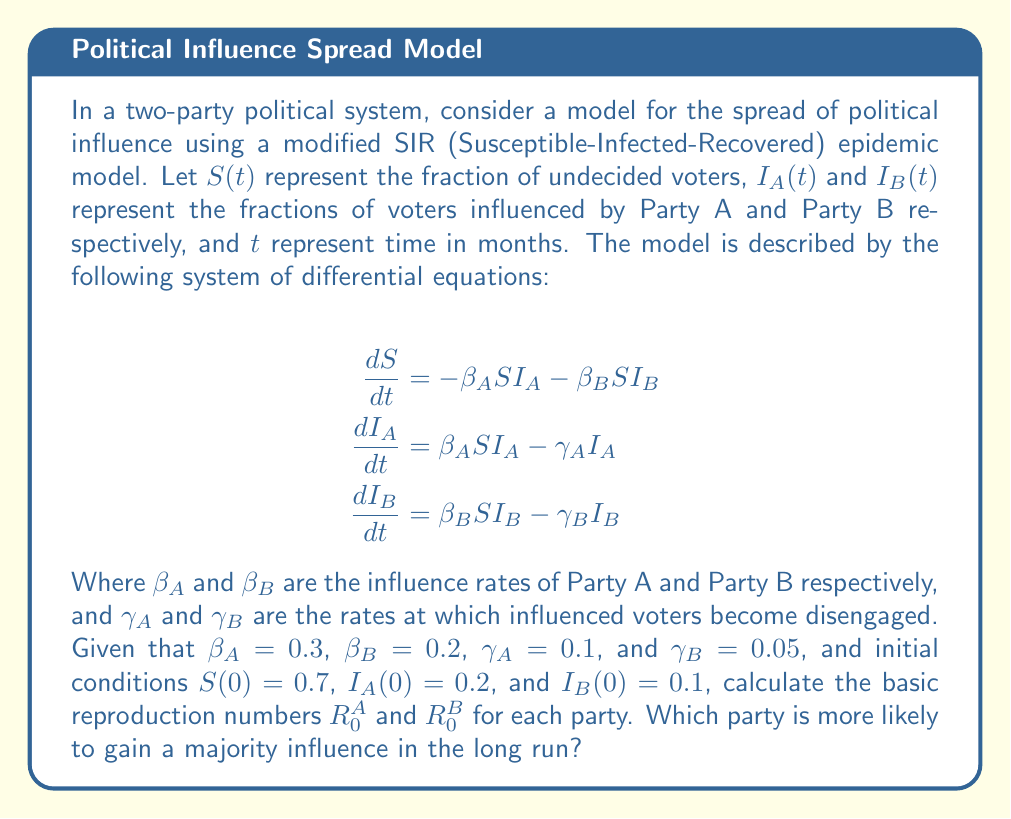Can you answer this question? To solve this problem, we need to understand the concept of the basic reproduction number ($R_0$) in epidemic models and how it applies to our political influence model.

1) In epidemiology, the basic reproduction number $R_0$ represents the average number of secondary infections caused by one infected individual in a completely susceptible population. In our political context, it represents the average number of new supporters a single supporter can generate in a completely undecided population.

2) For our model, we can calculate $R_0$ for each party using the formula:

   $R_0 = \frac{\beta S(0)}{\gamma}$

   Where $\beta$ is the influence rate, $S(0)$ is the initial susceptible (undecided) population, and $\gamma$ is the rate at which influenced voters become disengaged.

3) For Party A:
   $R_0^A = \frac{\beta_A S(0)}{\gamma_A} = \frac{0.3 \times 0.7}{0.1} = 2.1$

4) For Party B:
   $R_0^B = \frac{\beta_B S(0)}{\gamma_B} = \frac{0.2 \times 0.7}{0.05} = 2.8$

5) In epidemic models, when $R_0 > 1$, the infection will spread exponentially. In our political context, this means the party's influence will grow. The party with the higher $R_0$ is likely to gain majority influence in the long run.

6) Comparing $R_0^A$ and $R_0^B$, we see that $R_0^B > R_0^A$.

Therefore, Party B is more likely to gain a majority influence in the long run, despite starting with a smaller initial influenced population. This is because Party B has a higher basic reproduction number, indicating that each of its supporters is more effective at spreading influence and the party is better at retaining its supporters (lower $\gamma_B$).
Answer: $R_0^A = 2.1$, $R_0^B = 2.8$. Party B is more likely to gain a majority influence in the long run. 